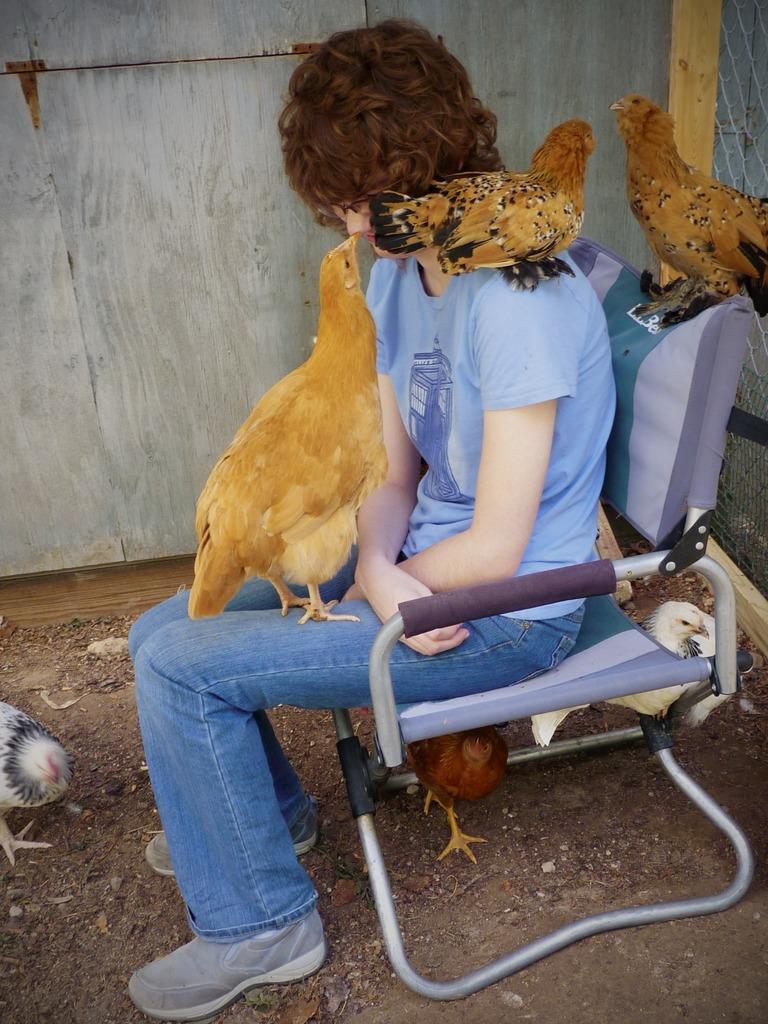Could you give a brief overview of what you see in this image? In the image there is a person sitting on a chair and around the person there are three hens and below the chair there are two hens, in the background there is a wooden wall, the chair is kept on a soil surface. 